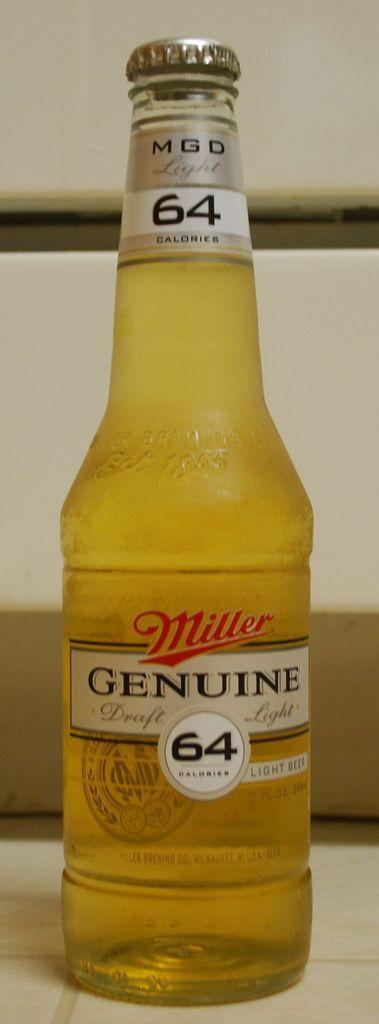Please provide a concise description of this image. In the picture there is a bottle on the ground. On the bottle there is a label and a lid. 